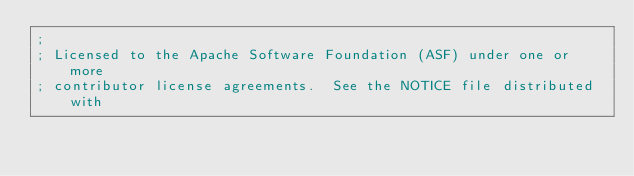<code> <loc_0><loc_0><loc_500><loc_500><_Clojure_>;
; Licensed to the Apache Software Foundation (ASF) under one or more
; contributor license agreements.  See the NOTICE file distributed with</code> 